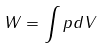Convert formula to latex. <formula><loc_0><loc_0><loc_500><loc_500>W = \int p d V</formula> 